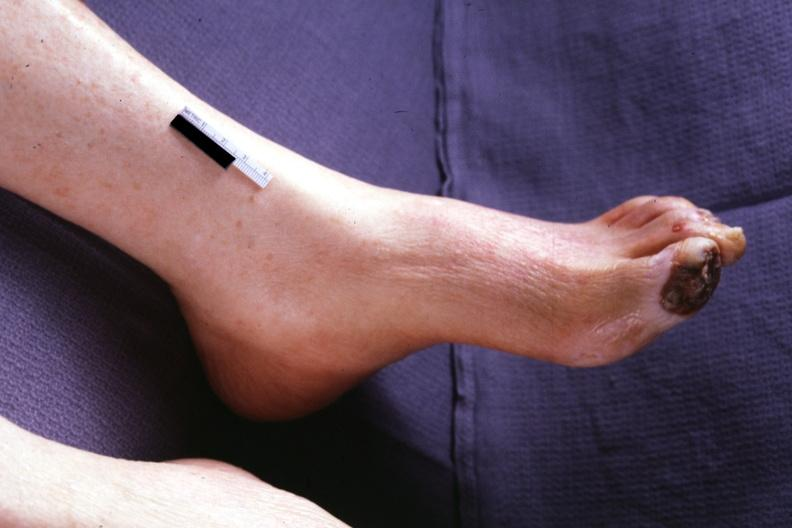re extremities present?
Answer the question using a single word or phrase. Yes 